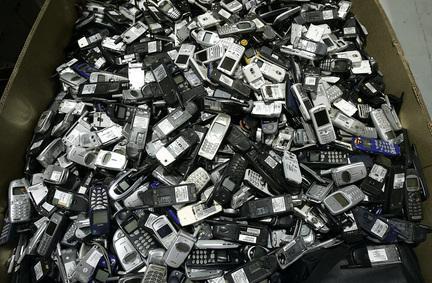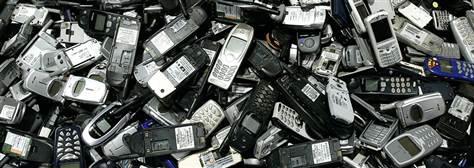The first image is the image on the left, the second image is the image on the right. Evaluate the accuracy of this statement regarding the images: "The left image shows a pile of phones in a visible container with sides, and the right image shows a pile of phones - including at least two blue ones - with no container.". Is it true? Answer yes or no. Yes. The first image is the image on the left, the second image is the image on the right. For the images displayed, is the sentence "In at least one image there is one layer of phones laying on a white table." factually correct? Answer yes or no. No. 